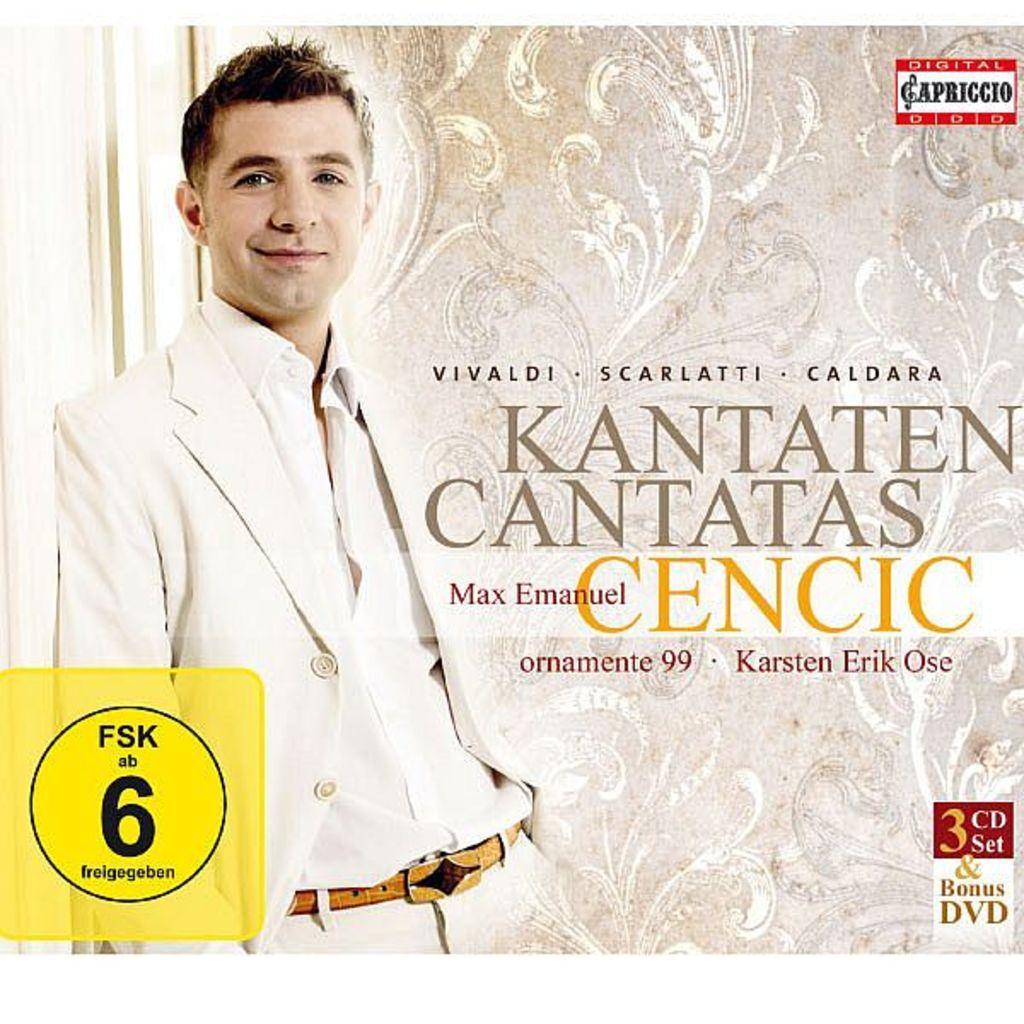In one or two sentences, can you explain what this image depicts? In this image I can see a person wearing white shirt, white jacket and white pant is standing and smiling. In the background I can see the wall which is designed and I can see few words written on the image. 